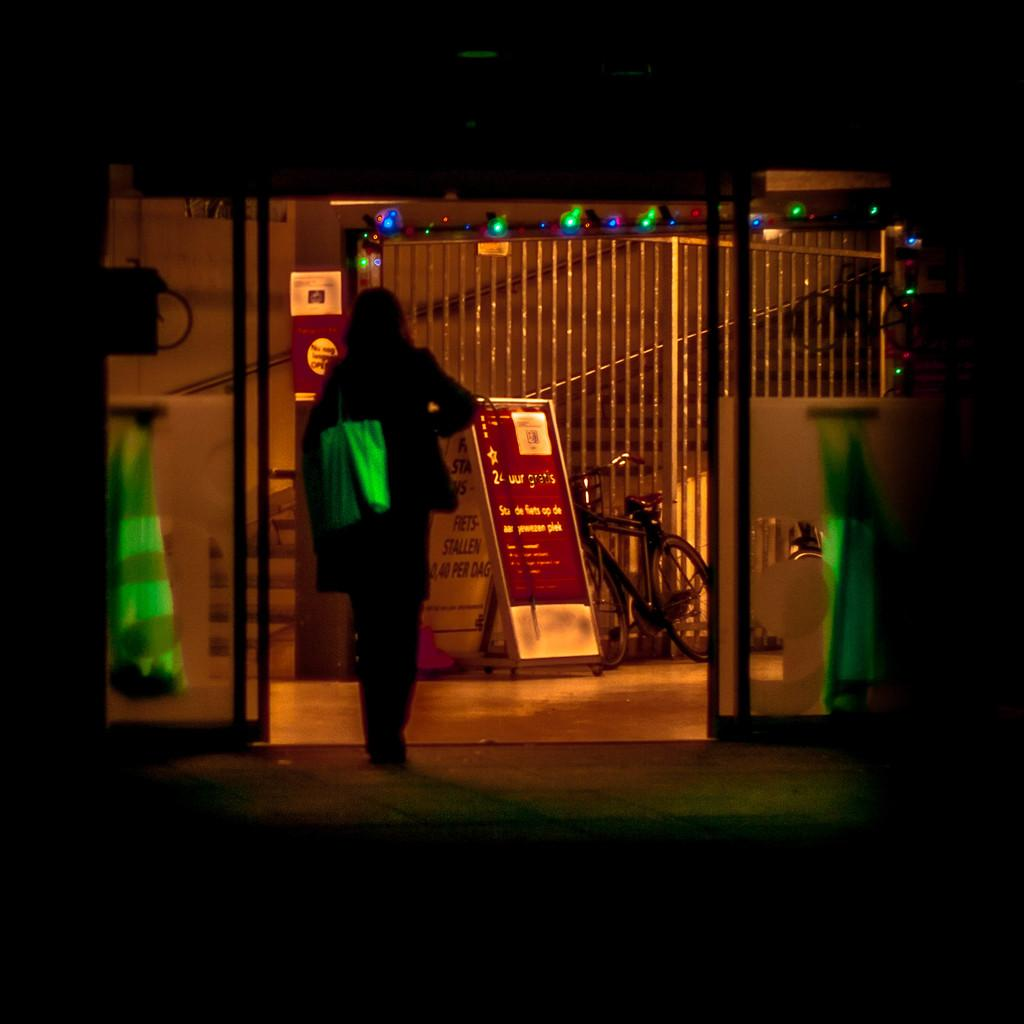What can be seen in the image? There is a person in the image, and they are wearing a handbag. The person is walking on the ground. There is also a bicycle, railing, boards, lights, stairs, a box, and other unspecified objects in the image. What is the person in the image carrying? The person in the image is carrying a handbag. What type of terrain is the person walking on? The person is walking on the ground. What mode of transportation is present in the image? There is a bicycle in the image. What architectural features can be seen in the image? There is railing, stairs, and a box in the image. What lighting is present in the image? There are lights in the image. What other objects can be seen in the image? There are boards and other unspecified objects in the image. What type of trains can be seen in the image? There are no trains present in the image. What type of drug is the person in the image using? There is no indication in the image that the person is using any drugs. 